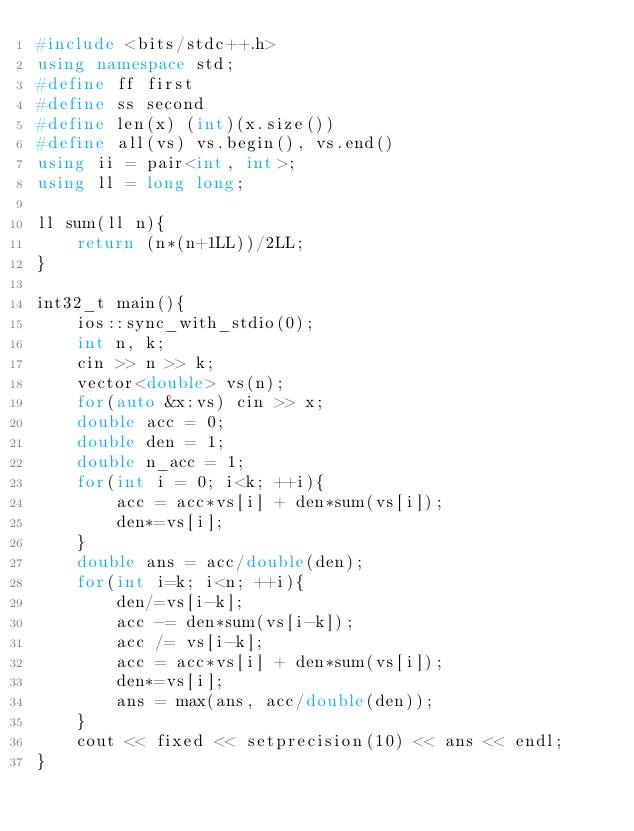<code> <loc_0><loc_0><loc_500><loc_500><_C++_>#include <bits/stdc++.h>
using namespace std;
#define ff first
#define ss second
#define len(x) (int)(x.size())
#define all(vs) vs.begin(), vs.end()
using ii = pair<int, int>;
using ll = long long;

ll sum(ll n){
	return (n*(n+1LL))/2LL;
}

int32_t main(){
	ios::sync_with_stdio(0);	
	int n, k;
	cin >> n >> k;
	vector<double> vs(n);
	for(auto &x:vs) cin >> x;
	double acc = 0;
	double den = 1;
	double n_acc = 1;
	for(int i = 0; i<k; ++i){
		acc = acc*vs[i] + den*sum(vs[i]);
		den*=vs[i];
	}
	double ans = acc/double(den);
	for(int i=k; i<n; ++i){
		den/=vs[i-k];
		acc -= den*sum(vs[i-k]);
		acc /= vs[i-k];
		acc = acc*vs[i] + den*sum(vs[i]);
		den*=vs[i];
		ans = max(ans, acc/double(den));
	}
	cout << fixed << setprecision(10) << ans << endl;
}
</code> 